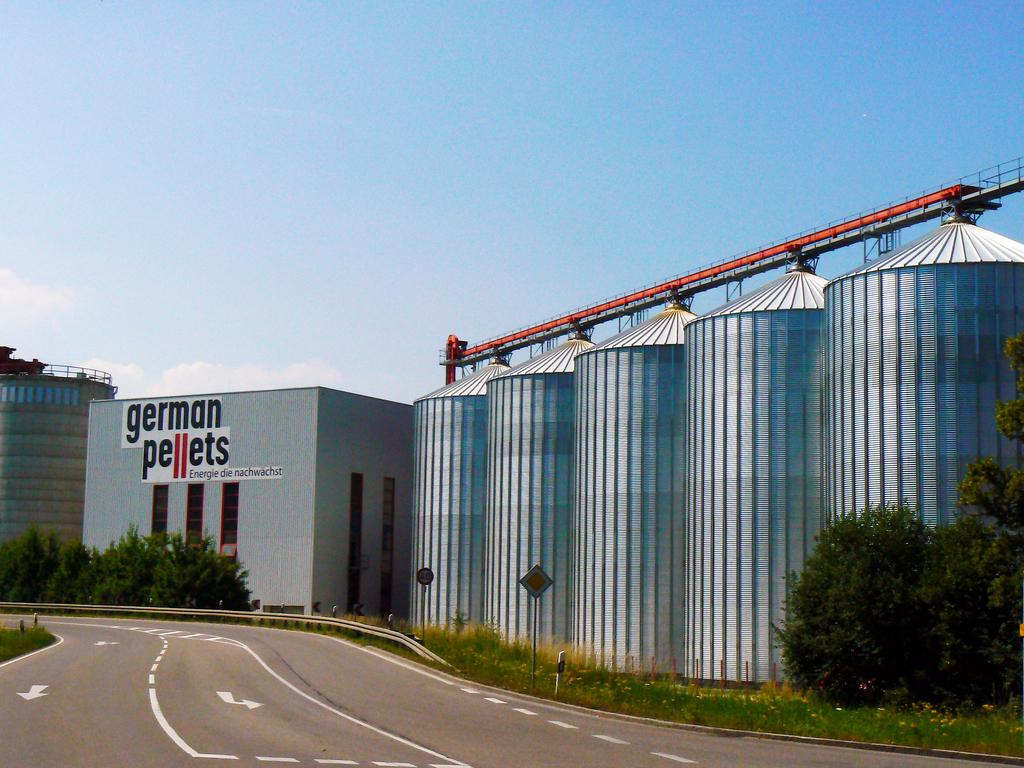What type of structures can be seen in the image? There are buildings in the image. What natural elements are present in the image? There are trees in the image. What man-made objects can be seen in the image? There are sign boards and metal barrels in the image. How would you describe the sky in the image? The sky is blue and cloudy in the image. What type of net is being used for dinner in the image? There is no net or dinner present in the image; it features buildings, trees, sign boards, metal barrels, and a blue, cloudy sky. 